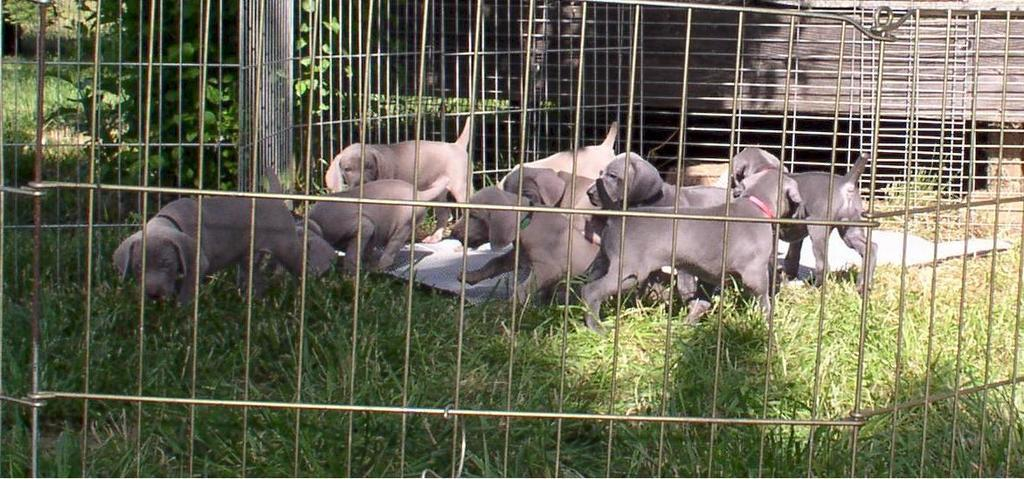What animals are present in the image? There is a group of dogs in the image. What are the dogs doing in the image? The dogs are playing on the ground. How are the dogs contained in the image? The dogs are kept in a metal cage. What type of vegetation can be seen at the bottom of the image? There is grass at the bottom of the image. What type of material is visible in the background of the image? There is a wooden wall in the background of the image. What type of linen is being used to dry the dogs in the image? There is no linen present in the image, and the dogs are not being dried. 